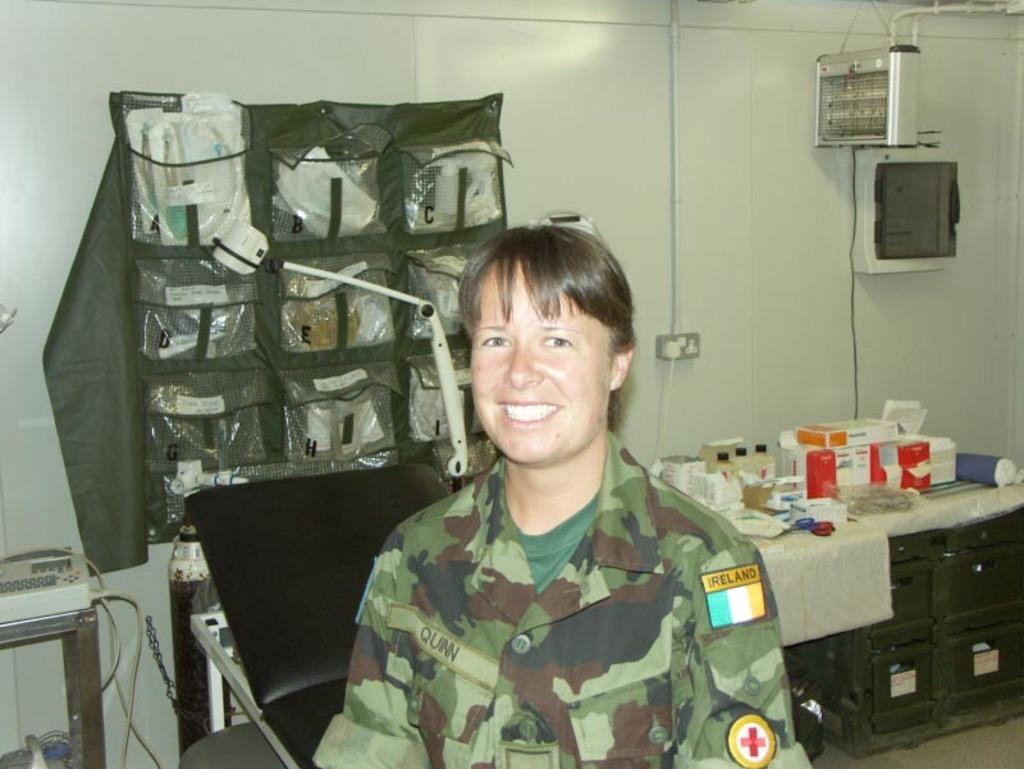How would you summarize this image in a sentence or two? In this image we can see a person. On the backside we can see a device on a table, a bed and some objects. We can also see a bottle, containers, scissors and some objects placed on a table, a cloth with some pouches on a wall, a switch board with a plug and some devices and a pipe on a wall. 